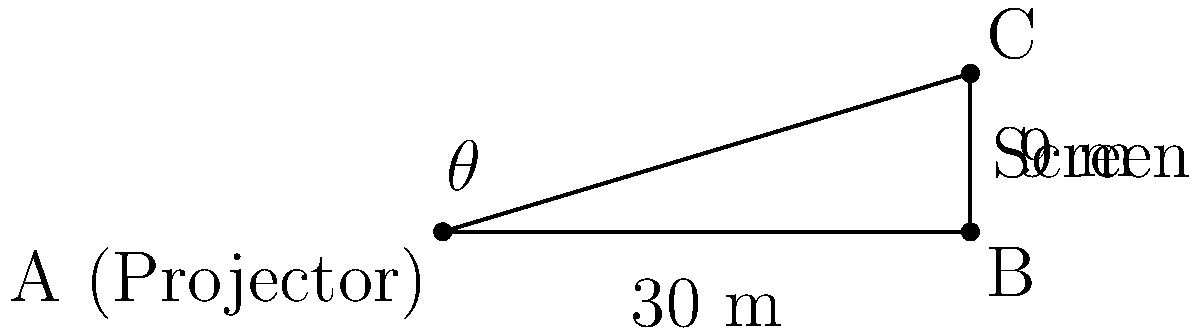For an outdoor film screening in a natural amphitheater, you need to set up a projector screen. The base of the screen is 30 meters away from the projector, and the top of the screen is 9 meters higher than its base. What should be the angle of elevation ($\theta$) for the projector to aim at the top of the screen for optimal viewing? To solve this problem, we'll use trigonometry, specifically the tangent function. Let's approach this step-by-step:

1) We have a right-angled triangle where:
   - The adjacent side (distance from projector to screen base) is 30 meters
   - The opposite side (height difference between screen base and top) is 9 meters
   - We need to find the angle $\theta$

2) The tangent of an angle in a right-angled triangle is defined as:

   $\tan(\theta) = \frac{\text{opposite}}{\text{adjacent}}$

3) Substituting our values:

   $\tan(\theta) = \frac{9}{30}$

4) To find $\theta$, we need to use the inverse tangent (arctan or $\tan^{-1}$):

   $\theta = \tan^{-1}(\frac{9}{30})$

5) Simplifying the fraction:

   $\theta = \tan^{-1}(0.3)$

6) Using a calculator or trigonometric tables:

   $\theta \approx 16.70^\circ$

Therefore, the angle of elevation for the projector should be approximately 16.70°.
Answer: $16.70^\circ$ 